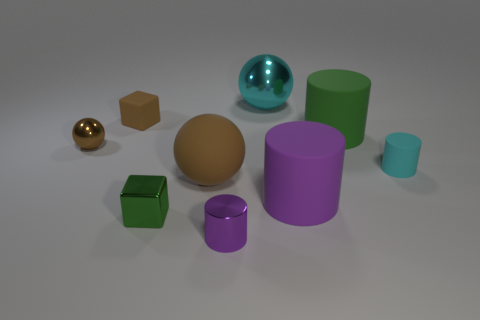There is a small rubber object on the right side of the green rubber thing; is it the same color as the big matte cylinder that is to the right of the large purple rubber object? no 